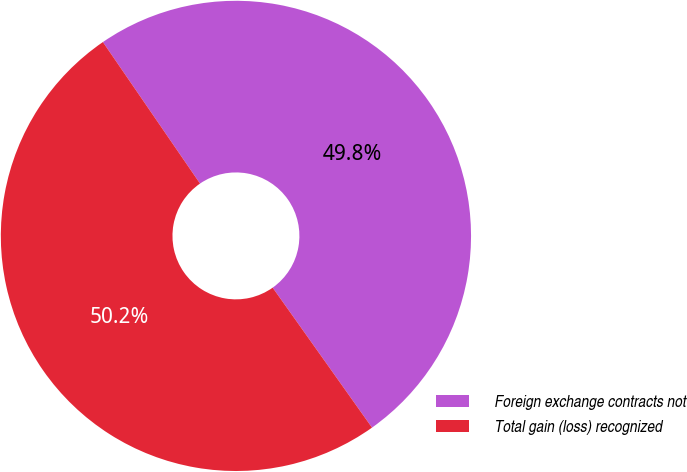<chart> <loc_0><loc_0><loc_500><loc_500><pie_chart><fcel>Foreign exchange contracts not<fcel>Total gain (loss) recognized<nl><fcel>49.75%<fcel>50.25%<nl></chart> 